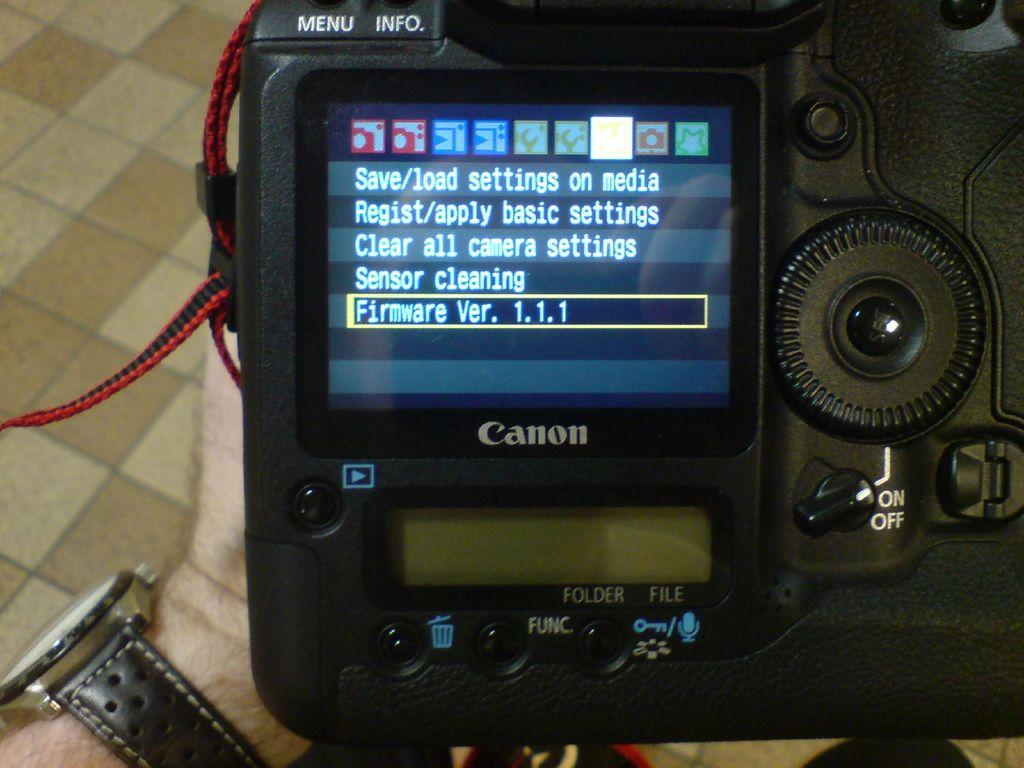<image>
Present a compact description of the photo's key features. The display of a Canon camera give options to the user. 